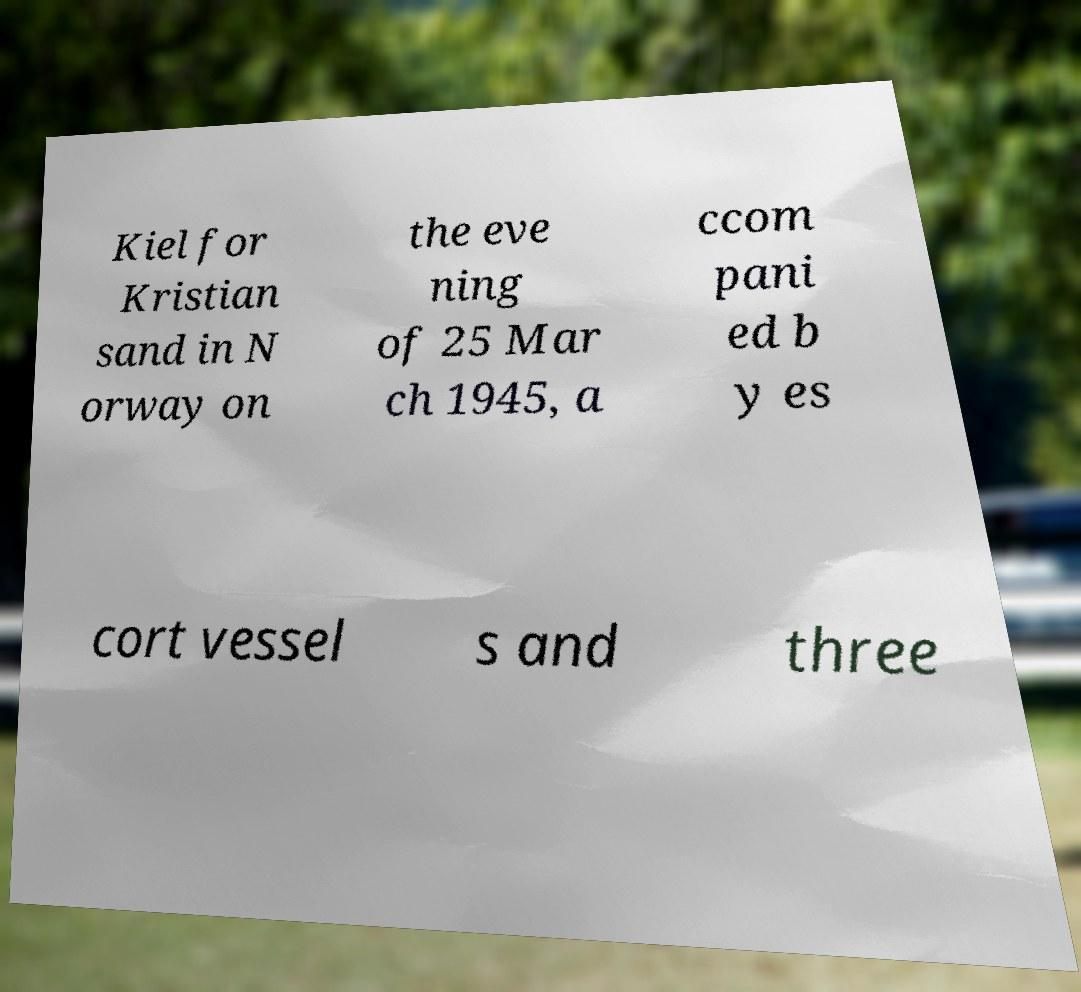For documentation purposes, I need the text within this image transcribed. Could you provide that? Kiel for Kristian sand in N orway on the eve ning of 25 Mar ch 1945, a ccom pani ed b y es cort vessel s and three 